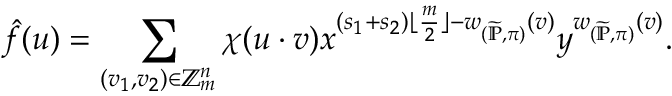Convert formula to latex. <formula><loc_0><loc_0><loc_500><loc_500>\hat { f } ( u ) = \sum _ { ( v _ { 1 } , v _ { 2 } ) \in \mathbb { Z } _ { m } ^ { n } } \chi ( u \cdot v ) x ^ { ( s _ { 1 } + s _ { 2 } ) \lfloor \frac { m } { 2 } \rfloor - w _ { ( \widetilde { \mathbb { P } } , \pi ) } ( v ) } y ^ { w _ { ( \widetilde { \mathbb { P } } , \pi ) } ( v ) } .</formula> 